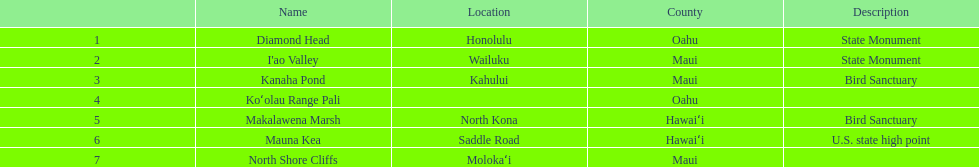Other than mauna kea, name a place in hawaii. Makalawena Marsh. 